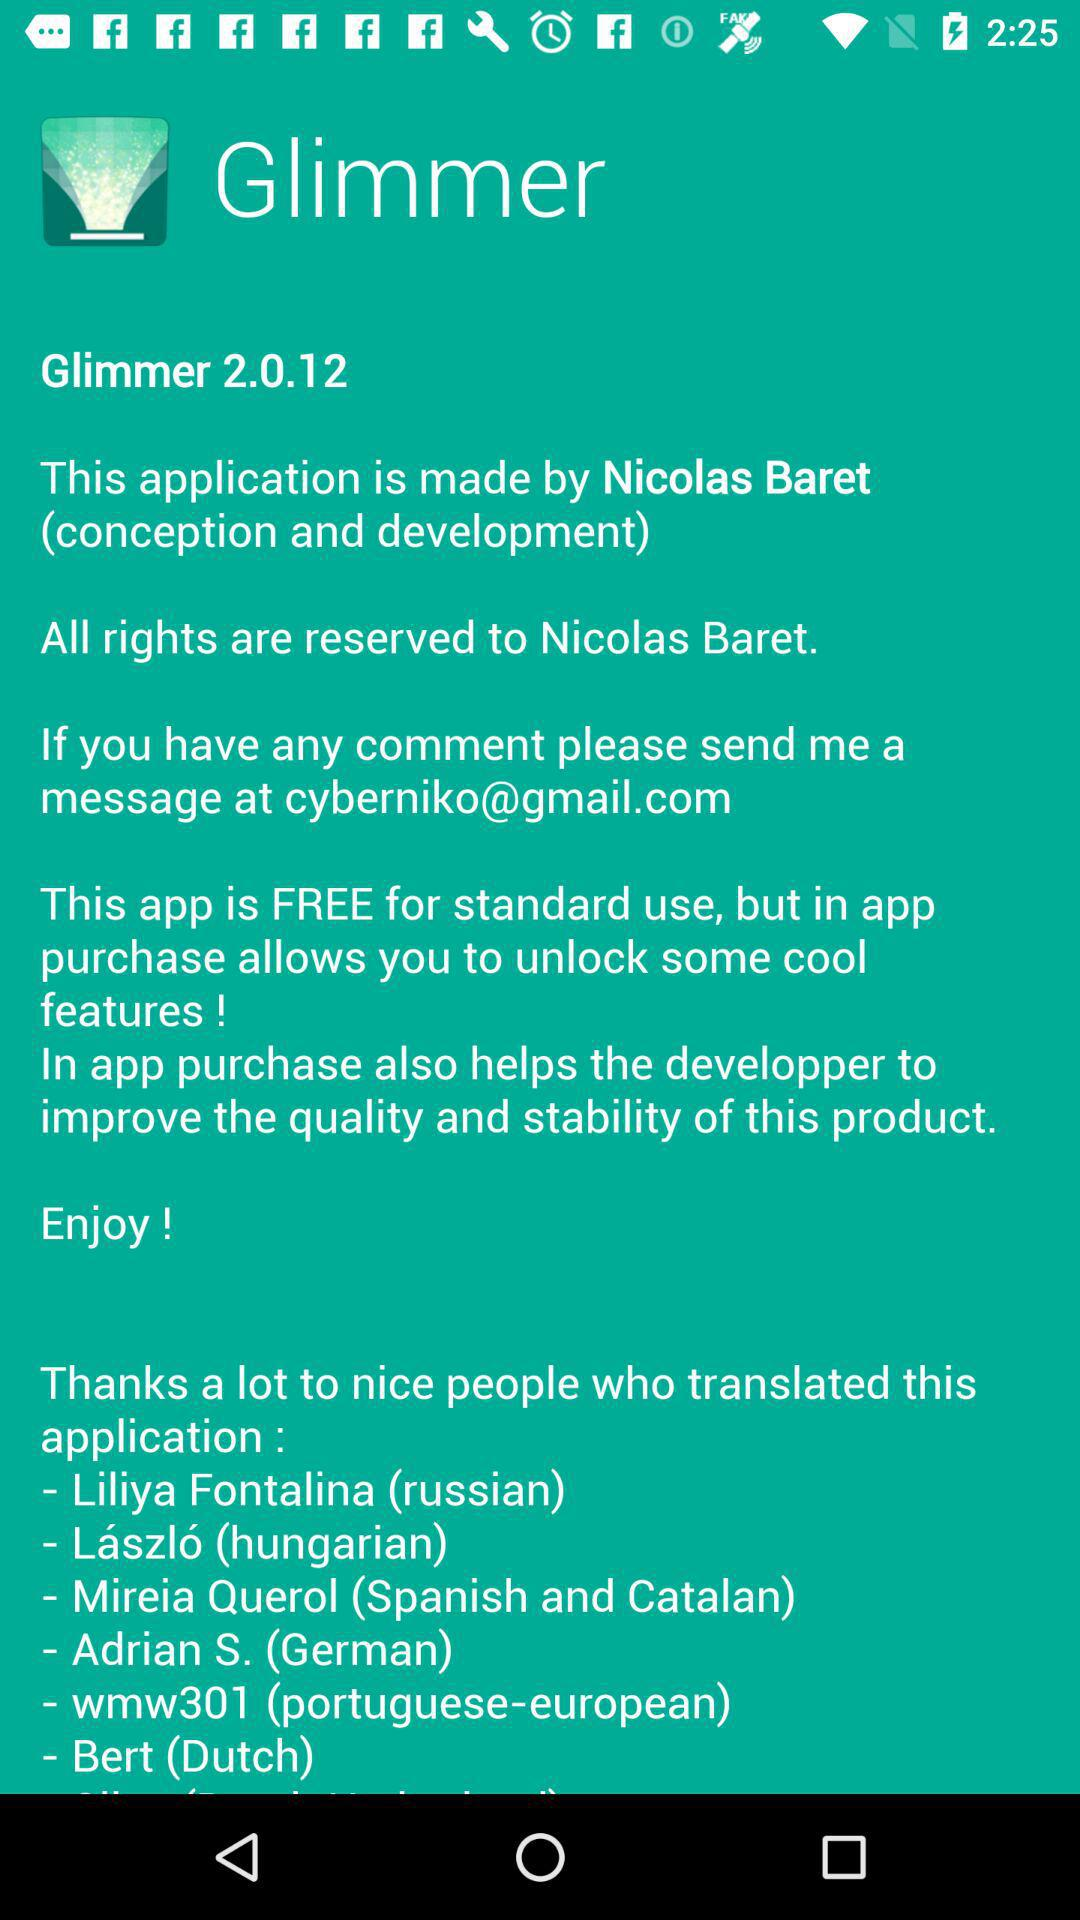What is the email for contact? The email for contact is cyberniko@gmail.com. 